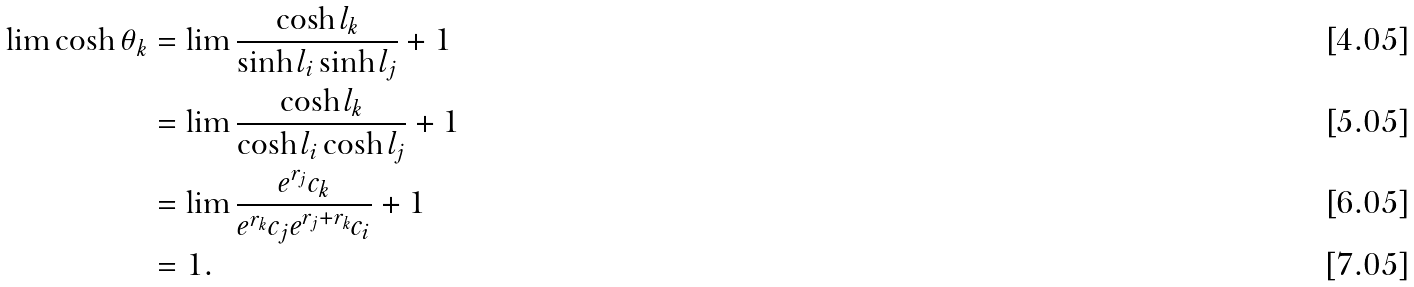Convert formula to latex. <formula><loc_0><loc_0><loc_500><loc_500>\lim \cosh \theta _ { k } & = \lim \frac { \cosh l _ { k } } { \sinh l _ { i } \sinh l _ { j } } + 1 \\ & = \lim \frac { \cosh l _ { k } } { \cosh l _ { i } \cosh l _ { j } } + 1 \\ & = \lim \frac { e ^ { r _ { j } } c _ { k } } { e ^ { r _ { k } } c _ { j } e ^ { r _ { j } + r _ { k } } c _ { i } } + 1 \\ & = 1 .</formula> 